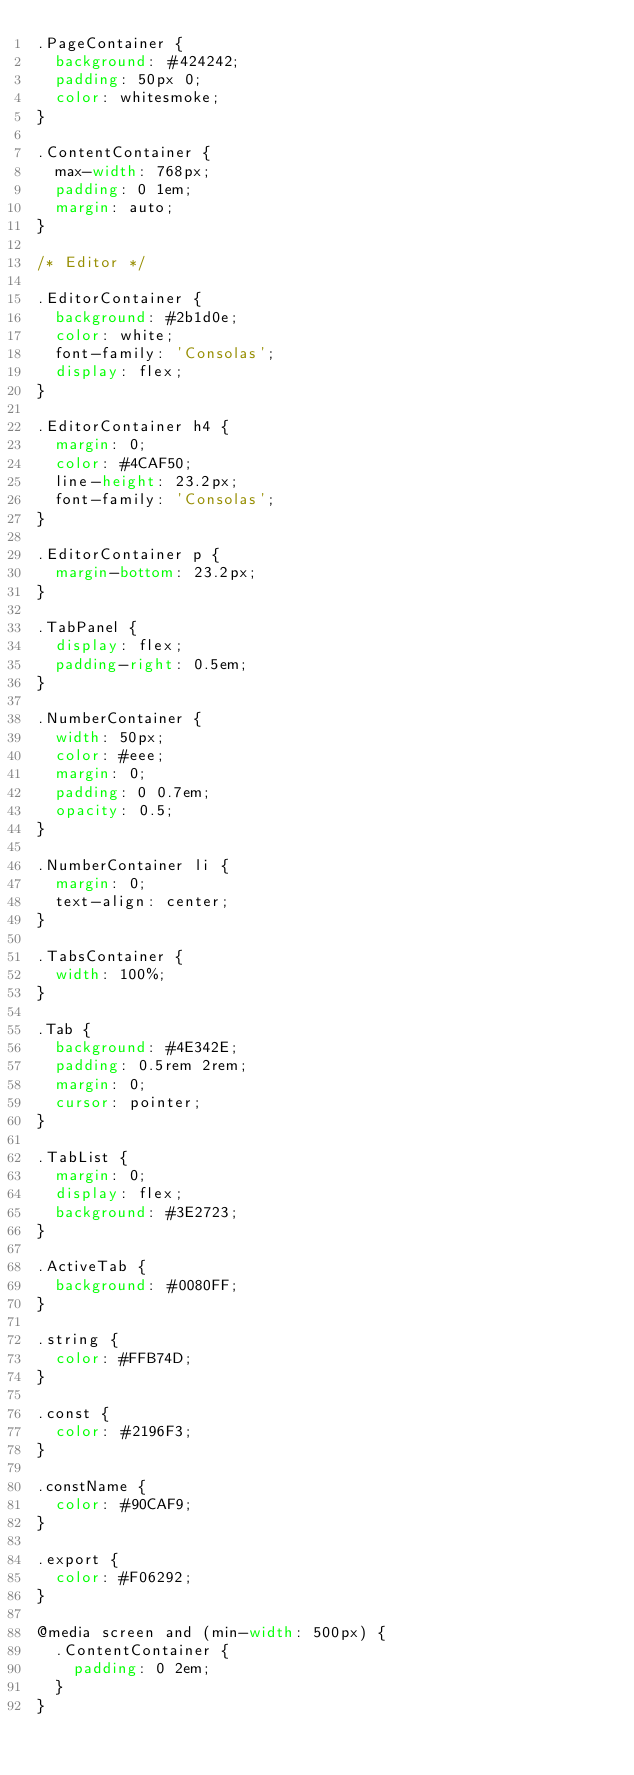Convert code to text. <code><loc_0><loc_0><loc_500><loc_500><_CSS_>.PageContainer {
  background: #424242;
  padding: 50px 0;
  color: whitesmoke;
}

.ContentContainer {
  max-width: 768px;
  padding: 0 1em;
  margin: auto;
}

/* Editor */

.EditorContainer {
  background: #2b1d0e;
  color: white;
  font-family: 'Consolas';
  display: flex;
}

.EditorContainer h4 {
  margin: 0;
  color: #4CAF50;
  line-height: 23.2px;
  font-family: 'Consolas';
}

.EditorContainer p {
  margin-bottom: 23.2px;
}

.TabPanel {
  display: flex;
  padding-right: 0.5em;
}

.NumberContainer {
  width: 50px;
  color: #eee;
  margin: 0;
  padding: 0 0.7em;
  opacity: 0.5;
}

.NumberContainer li {
  margin: 0;
  text-align: center;
}

.TabsContainer {
  width: 100%;
}

.Tab {
  background: #4E342E;
  padding: 0.5rem 2rem;
  margin: 0;
  cursor: pointer;
}

.TabList {
  margin: 0;
  display: flex;
  background: #3E2723;
}

.ActiveTab {
  background: #0080FF;
}

.string {
  color: #FFB74D;
}

.const {
  color: #2196F3;
}

.constName {
  color: #90CAF9;
}

.export {
  color: #F06292;
}

@media screen and (min-width: 500px) {
  .ContentContainer {
    padding: 0 2em;
  }
}</code> 